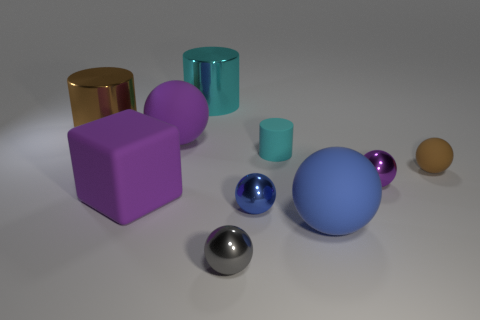Subtract all cyan cylinders. How many were subtracted if there are1cyan cylinders left? 1 Subtract all small rubber spheres. How many spheres are left? 5 Subtract all gray balls. How many balls are left? 5 Subtract 0 yellow cubes. How many objects are left? 10 Subtract all balls. How many objects are left? 4 Subtract 1 cylinders. How many cylinders are left? 2 Subtract all brown cylinders. Subtract all yellow balls. How many cylinders are left? 2 Subtract all brown blocks. How many gray cylinders are left? 0 Subtract all large cyan metallic objects. Subtract all tiny green rubber things. How many objects are left? 9 Add 6 big purple rubber cubes. How many big purple rubber cubes are left? 7 